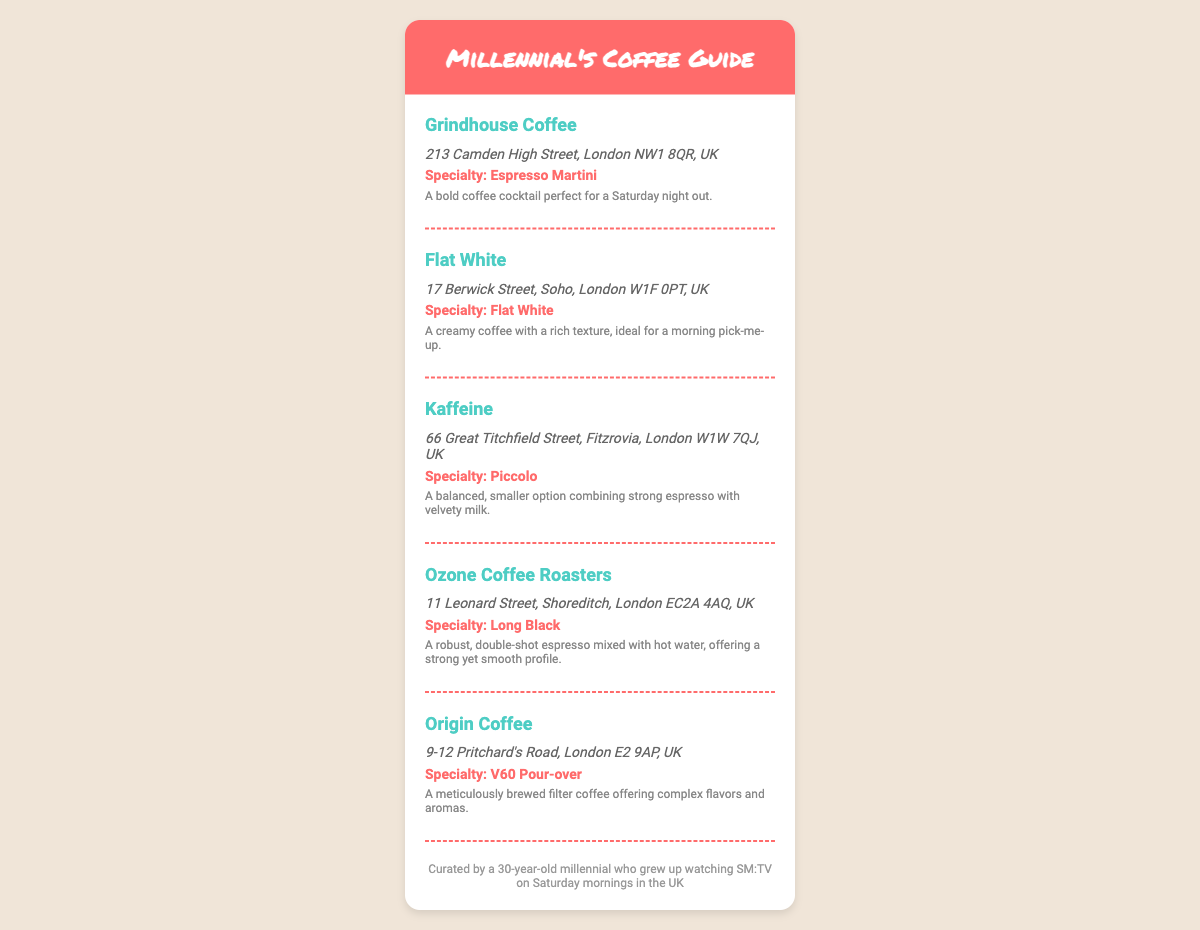What is the name of the first coffee shop listed? The first coffee shop mentioned in the document is Grindhouse Coffee.
Answer: Grindhouse Coffee What is the specialty drink at Flat White? Flat White's specialty drink is explicitly mentioned in the document as Flat White.
Answer: Flat White What is the address of Kaffeine? The address of Kaffeine is provided in the document as 66 Great Titchfield Street, Fitzrovia, London W1W 7QJ, UK.
Answer: 66 Great Titchfield Street, Fitzrovia, London W1W 7QJ, UK How many coffee shops are listed in the guide? The document lists a total of five coffee shops.
Answer: Five Which coffee shop offers a V60 Pour-over? The coffee shop that offers a V60 Pour-over is Origin Coffee.
Answer: Origin Coffee What type of coffee is served at Ozone Coffee Roasters? Ozone Coffee Roasters serves a Long Black, as mentioned in the specialty section of the document.
Answer: Long Black What is the unique feature of the descriptions provided for each coffee shop? The descriptions for each coffee shop offer a brief insight into the specialty drink's characteristics and appeal.
Answer: Specialty drink characteristics What is the primary audience intended for the document? The document is curated for millennials, as indicated in the footer note.
Answer: Millennials 